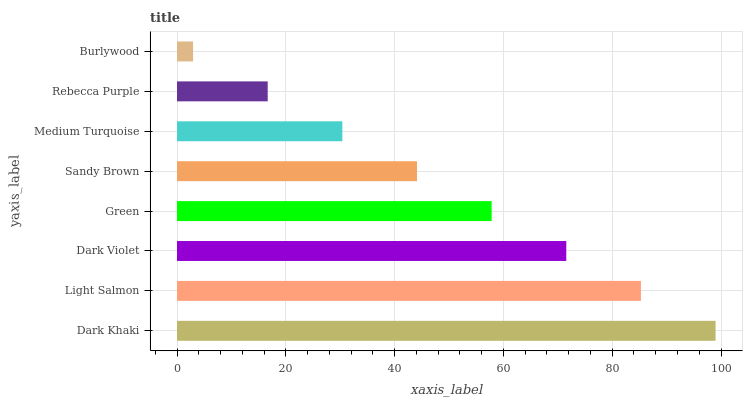Is Burlywood the minimum?
Answer yes or no. Yes. Is Dark Khaki the maximum?
Answer yes or no. Yes. Is Light Salmon the minimum?
Answer yes or no. No. Is Light Salmon the maximum?
Answer yes or no. No. Is Dark Khaki greater than Light Salmon?
Answer yes or no. Yes. Is Light Salmon less than Dark Khaki?
Answer yes or no. Yes. Is Light Salmon greater than Dark Khaki?
Answer yes or no. No. Is Dark Khaki less than Light Salmon?
Answer yes or no. No. Is Green the high median?
Answer yes or no. Yes. Is Sandy Brown the low median?
Answer yes or no. Yes. Is Dark Khaki the high median?
Answer yes or no. No. Is Dark Violet the low median?
Answer yes or no. No. 